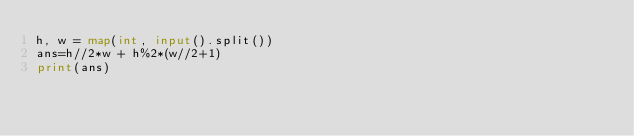<code> <loc_0><loc_0><loc_500><loc_500><_Python_>h, w = map(int, input().split())
ans=h//2*w + h%2*(w//2+1)
print(ans)
</code> 